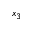<formula> <loc_0><loc_0><loc_500><loc_500>x _ { 3 }</formula> 